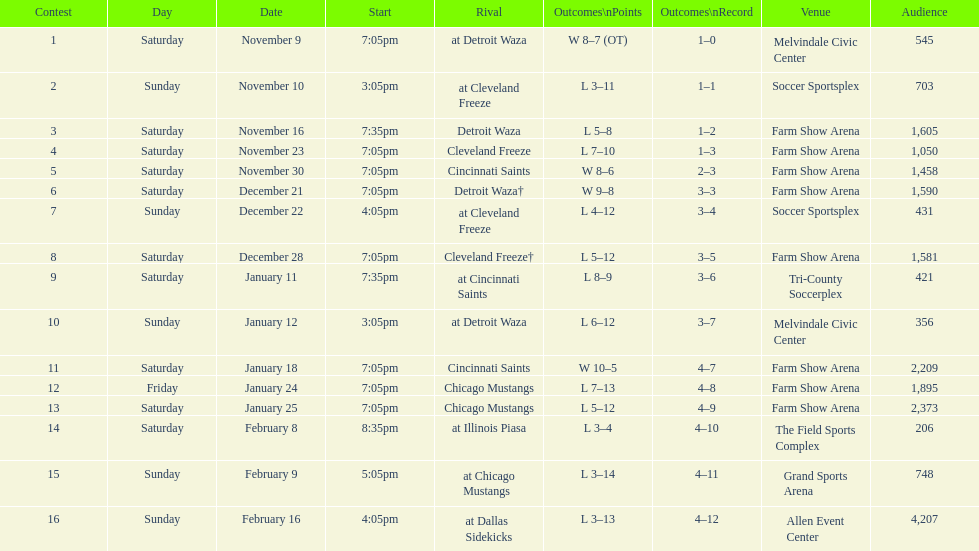How many times did the team play at home but did not win? 5. 